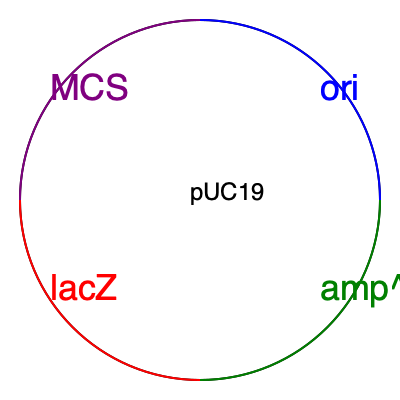Based on the plasmid map of pUC19 shown above, which gene would you disrupt to select for transformed bacteria on ampicillin-containing media, and what potential limitation might this approach have in a real-world bioengineering application? To answer this question, let's break it down step-by-step:

1. Plasmid components:
   - ori: Origin of replication
   - amp^R: Ampicillin resistance gene
   - lacZ: Beta-galactosidase gene
   - MCS: Multiple Cloning Site

2. Selection marker:
   - The amp^R gene confers resistance to ampicillin, allowing transformed bacteria to grow on ampicillin-containing media.

3. Gene disruption for selection:
   - To select for transformed bacteria on ampicillin-containing media, we would NOT disrupt the amp^R gene.
   - Instead, we would insert our gene of interest into the MCS, which may disrupt the lacZ gene.

4. Function of amp^R:
   - The amp^R gene produces beta-lactamase, an enzyme that breaks down ampicillin.
   - Bacteria containing the plasmid with an intact amp^R gene will survive on ampicillin-containing media.

5. Potential limitation in real-world bioengineering:
   - Antibiotic resistance genes like amp^R can potentially spread to other bacteria in the environment.
   - This could contribute to the growing problem of antibiotic-resistant bacteria in medical and agricultural settings.
   - Regulatory agencies might have concerns about the use of antibiotic resistance markers in genetically engineered organisms intended for release or commercial products.

6. Alternative approaches:
   - In advanced bioengineering applications, researchers might consider using alternative selection markers or marker-free systems to address these limitations.
   - Examples include auxotrophic markers, CRISPR-Cas9 based selection, or site-specific recombination systems for marker removal.
Answer: amp^R gene; potential spread of antibiotic resistance 